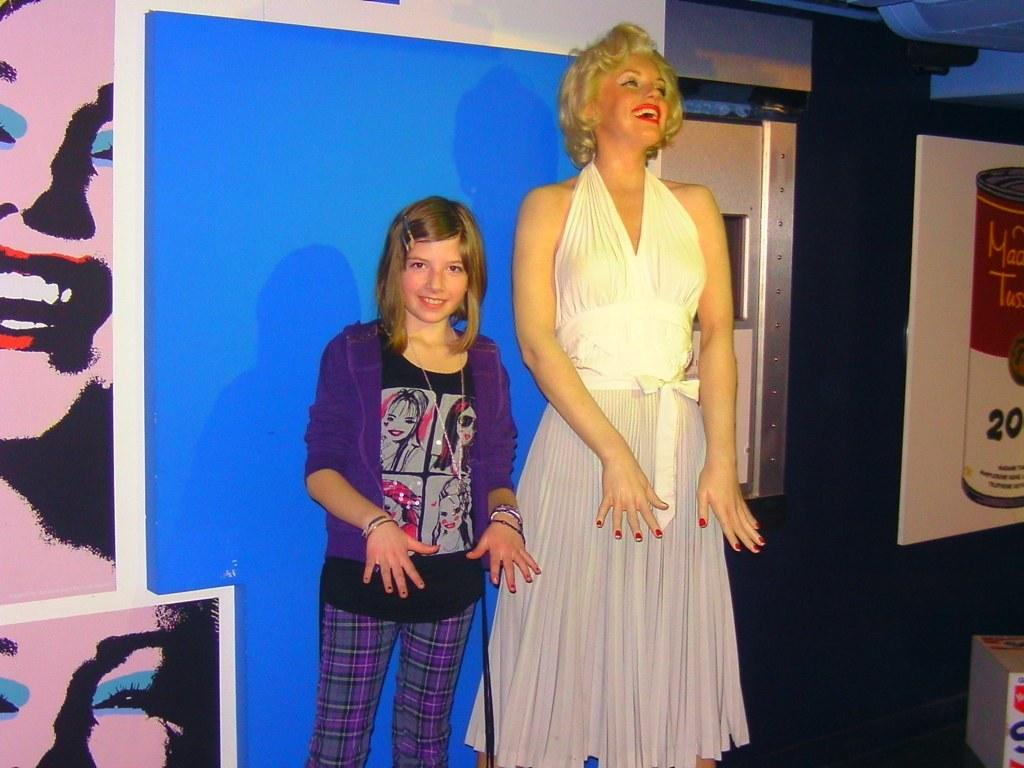Who is the main subject in the image? There is a girl in the image. Where is the girl positioned in the image? The girl is standing in the middle. What is the girl doing in the image? The girl is showing her hands. What color is the girl's sweater in the image? The girl is wearing a purple color sweater. Can you describe the other person in the image? There is a beautiful woman in the image. Where is the woman positioned in relation to the girl? The woman is standing beside the girl. What is the woman wearing in the image? The woman is wearing a white color dress. What expression does the woman have in the image? The woman is smiling. What type of stone can be seen in the woman's hand in the image? There is no stone present in the woman's hand or in the image. Is there a carriage visible in the background of the image? There is no carriage present in the image. 